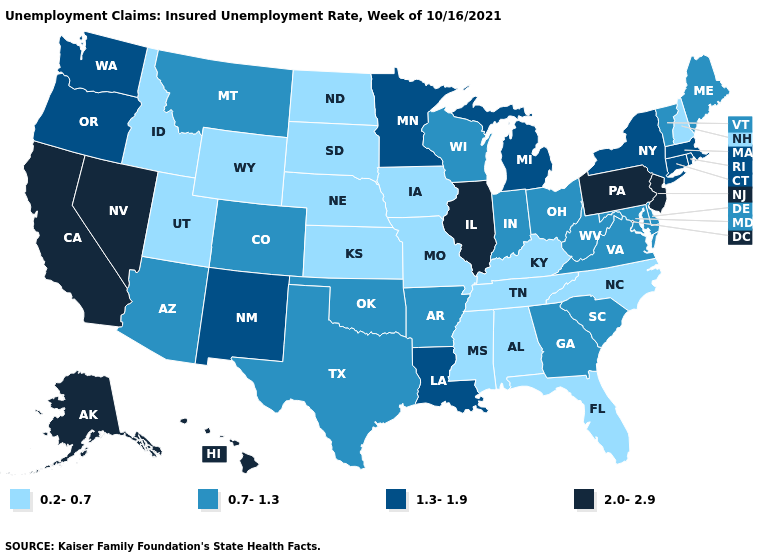What is the highest value in states that border Delaware?
Quick response, please. 2.0-2.9. Is the legend a continuous bar?
Write a very short answer. No. What is the value of South Carolina?
Write a very short answer. 0.7-1.3. Which states hav the highest value in the Northeast?
Write a very short answer. New Jersey, Pennsylvania. What is the value of New York?
Be succinct. 1.3-1.9. Among the states that border Mississippi , which have the lowest value?
Concise answer only. Alabama, Tennessee. What is the value of Alabama?
Give a very brief answer. 0.2-0.7. Name the states that have a value in the range 0.7-1.3?
Short answer required. Arizona, Arkansas, Colorado, Delaware, Georgia, Indiana, Maine, Maryland, Montana, Ohio, Oklahoma, South Carolina, Texas, Vermont, Virginia, West Virginia, Wisconsin. Does Virginia have the highest value in the USA?
Be succinct. No. What is the value of California?
Concise answer only. 2.0-2.9. Which states hav the highest value in the MidWest?
Be succinct. Illinois. What is the value of Nevada?
Short answer required. 2.0-2.9. Name the states that have a value in the range 0.2-0.7?
Quick response, please. Alabama, Florida, Idaho, Iowa, Kansas, Kentucky, Mississippi, Missouri, Nebraska, New Hampshire, North Carolina, North Dakota, South Dakota, Tennessee, Utah, Wyoming. What is the value of Louisiana?
Write a very short answer. 1.3-1.9. Does the first symbol in the legend represent the smallest category?
Write a very short answer. Yes. 